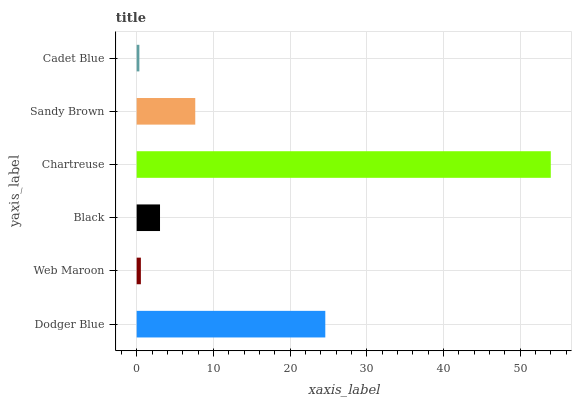Is Cadet Blue the minimum?
Answer yes or no. Yes. Is Chartreuse the maximum?
Answer yes or no. Yes. Is Web Maroon the minimum?
Answer yes or no. No. Is Web Maroon the maximum?
Answer yes or no. No. Is Dodger Blue greater than Web Maroon?
Answer yes or no. Yes. Is Web Maroon less than Dodger Blue?
Answer yes or no. Yes. Is Web Maroon greater than Dodger Blue?
Answer yes or no. No. Is Dodger Blue less than Web Maroon?
Answer yes or no. No. Is Sandy Brown the high median?
Answer yes or no. Yes. Is Black the low median?
Answer yes or no. Yes. Is Web Maroon the high median?
Answer yes or no. No. Is Chartreuse the low median?
Answer yes or no. No. 